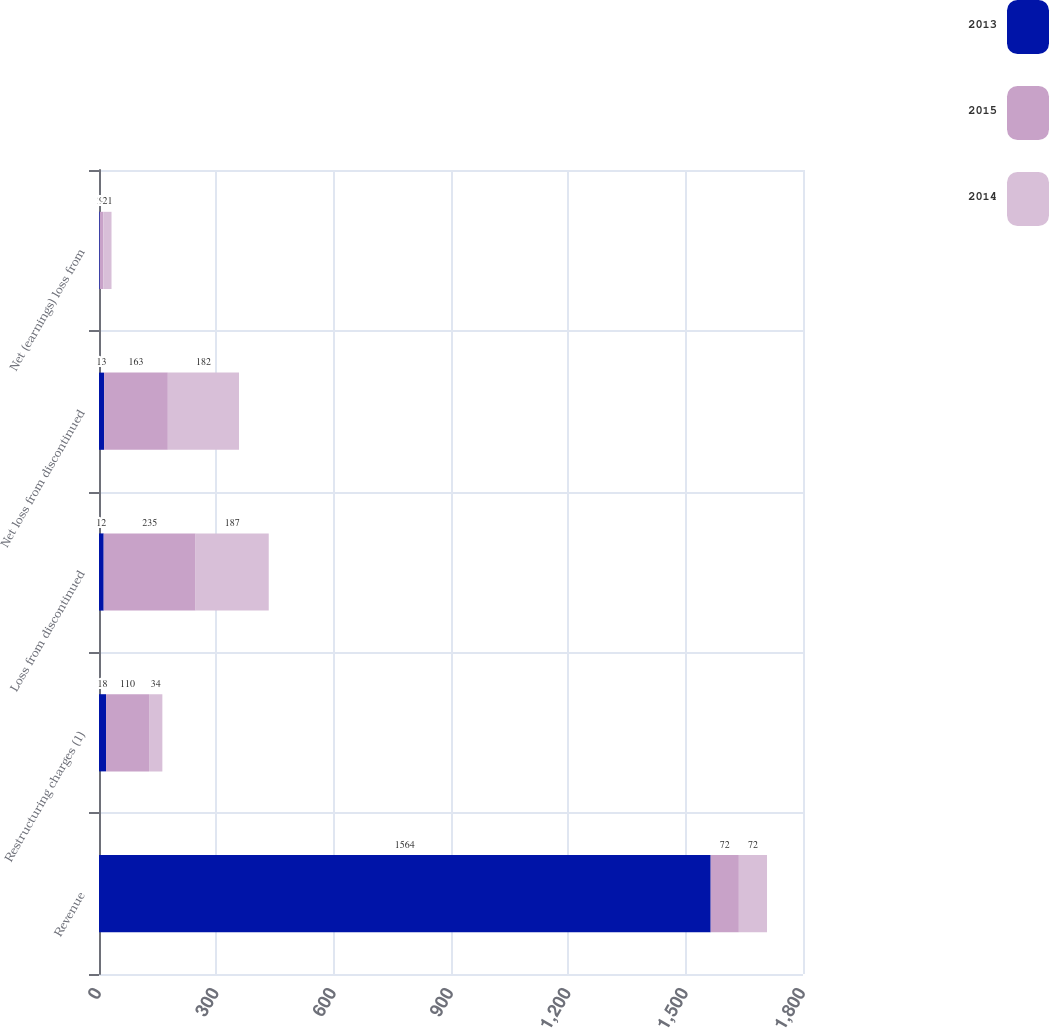Convert chart to OTSL. <chart><loc_0><loc_0><loc_500><loc_500><stacked_bar_chart><ecel><fcel>Revenue<fcel>Restructuring charges (1)<fcel>Loss from discontinued<fcel>Net loss from discontinued<fcel>Net (earnings) loss from<nl><fcel>2013<fcel>1564<fcel>18<fcel>12<fcel>13<fcel>2<nl><fcel>2015<fcel>72<fcel>110<fcel>235<fcel>163<fcel>9<nl><fcel>2014<fcel>72<fcel>34<fcel>187<fcel>182<fcel>21<nl></chart> 